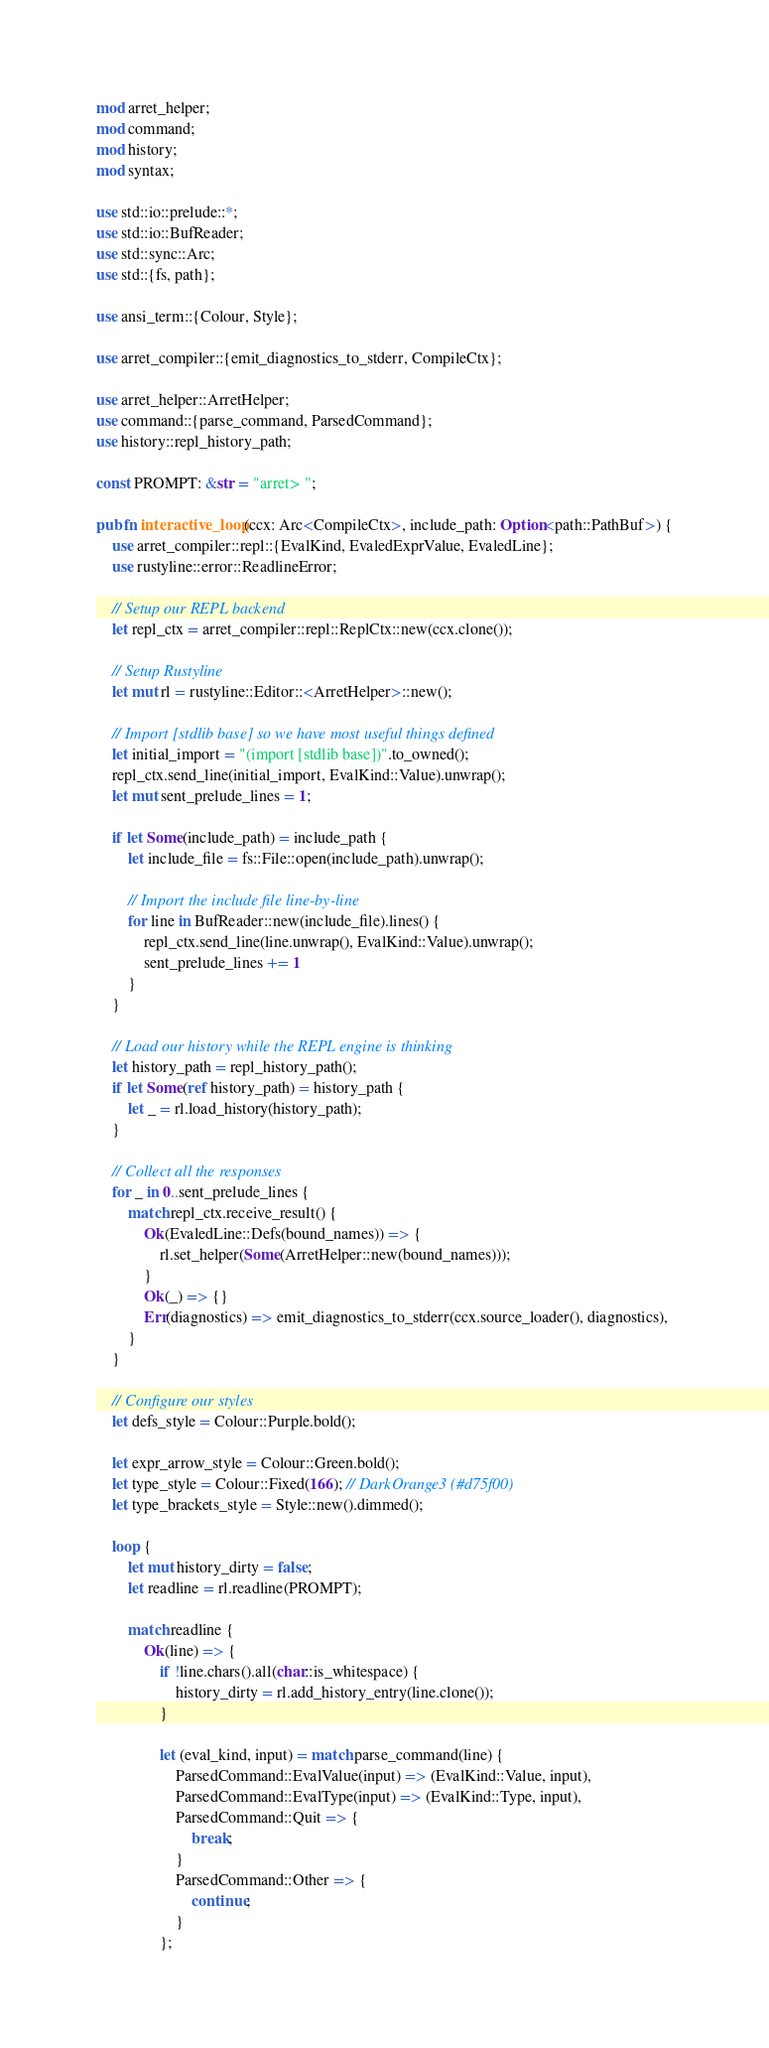<code> <loc_0><loc_0><loc_500><loc_500><_Rust_>mod arret_helper;
mod command;
mod history;
mod syntax;

use std::io::prelude::*;
use std::io::BufReader;
use std::sync::Arc;
use std::{fs, path};

use ansi_term::{Colour, Style};

use arret_compiler::{emit_diagnostics_to_stderr, CompileCtx};

use arret_helper::ArretHelper;
use command::{parse_command, ParsedCommand};
use history::repl_history_path;

const PROMPT: &str = "arret> ";

pub fn interactive_loop(ccx: Arc<CompileCtx>, include_path: Option<path::PathBuf>) {
    use arret_compiler::repl::{EvalKind, EvaledExprValue, EvaledLine};
    use rustyline::error::ReadlineError;

    // Setup our REPL backend
    let repl_ctx = arret_compiler::repl::ReplCtx::new(ccx.clone());

    // Setup Rustyline
    let mut rl = rustyline::Editor::<ArretHelper>::new();

    // Import [stdlib base] so we have most useful things defined
    let initial_import = "(import [stdlib base])".to_owned();
    repl_ctx.send_line(initial_import, EvalKind::Value).unwrap();
    let mut sent_prelude_lines = 1;

    if let Some(include_path) = include_path {
        let include_file = fs::File::open(include_path).unwrap();

        // Import the include file line-by-line
        for line in BufReader::new(include_file).lines() {
            repl_ctx.send_line(line.unwrap(), EvalKind::Value).unwrap();
            sent_prelude_lines += 1
        }
    }

    // Load our history while the REPL engine is thinking
    let history_path = repl_history_path();
    if let Some(ref history_path) = history_path {
        let _ = rl.load_history(history_path);
    }

    // Collect all the responses
    for _ in 0..sent_prelude_lines {
        match repl_ctx.receive_result() {
            Ok(EvaledLine::Defs(bound_names)) => {
                rl.set_helper(Some(ArretHelper::new(bound_names)));
            }
            Ok(_) => {}
            Err(diagnostics) => emit_diagnostics_to_stderr(ccx.source_loader(), diagnostics),
        }
    }

    // Configure our styles
    let defs_style = Colour::Purple.bold();

    let expr_arrow_style = Colour::Green.bold();
    let type_style = Colour::Fixed(166); // DarkOrange3 (#d75f00)
    let type_brackets_style = Style::new().dimmed();

    loop {
        let mut history_dirty = false;
        let readline = rl.readline(PROMPT);

        match readline {
            Ok(line) => {
                if !line.chars().all(char::is_whitespace) {
                    history_dirty = rl.add_history_entry(line.clone());
                }

                let (eval_kind, input) = match parse_command(line) {
                    ParsedCommand::EvalValue(input) => (EvalKind::Value, input),
                    ParsedCommand::EvalType(input) => (EvalKind::Type, input),
                    ParsedCommand::Quit => {
                        break;
                    }
                    ParsedCommand::Other => {
                        continue;
                    }
                };
</code> 